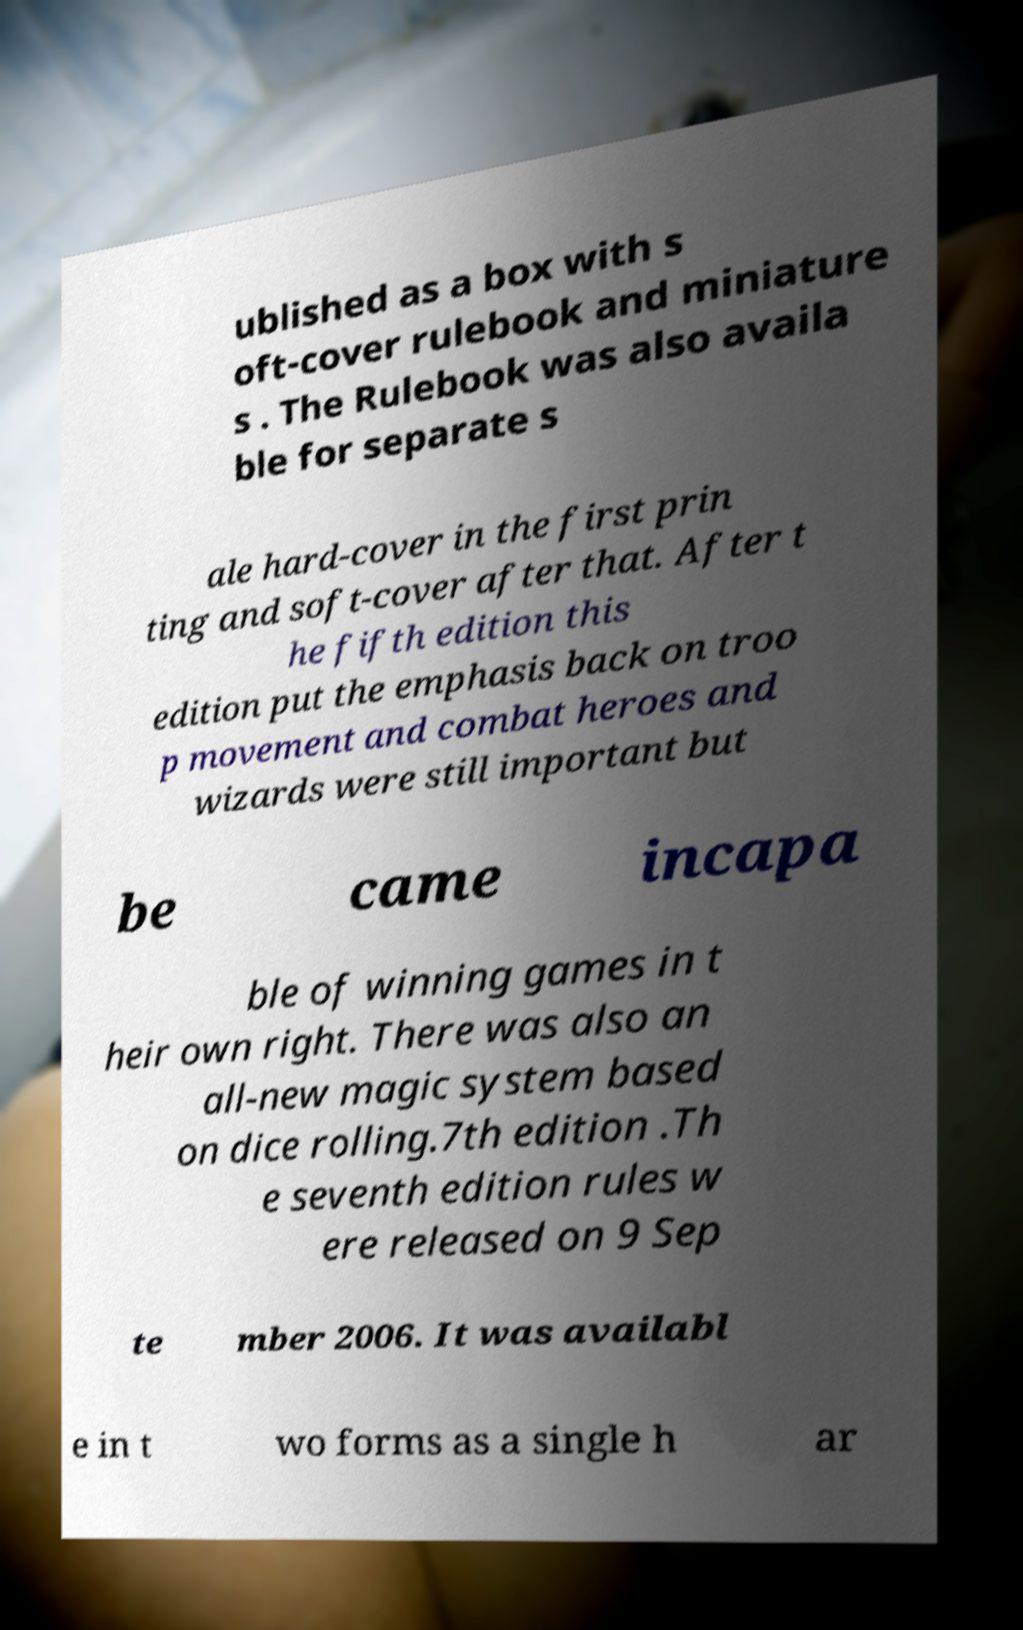Could you extract and type out the text from this image? ublished as a box with s oft-cover rulebook and miniature s . The Rulebook was also availa ble for separate s ale hard-cover in the first prin ting and soft-cover after that. After t he fifth edition this edition put the emphasis back on troo p movement and combat heroes and wizards were still important but be came incapa ble of winning games in t heir own right. There was also an all-new magic system based on dice rolling.7th edition .Th e seventh edition rules w ere released on 9 Sep te mber 2006. It was availabl e in t wo forms as a single h ar 